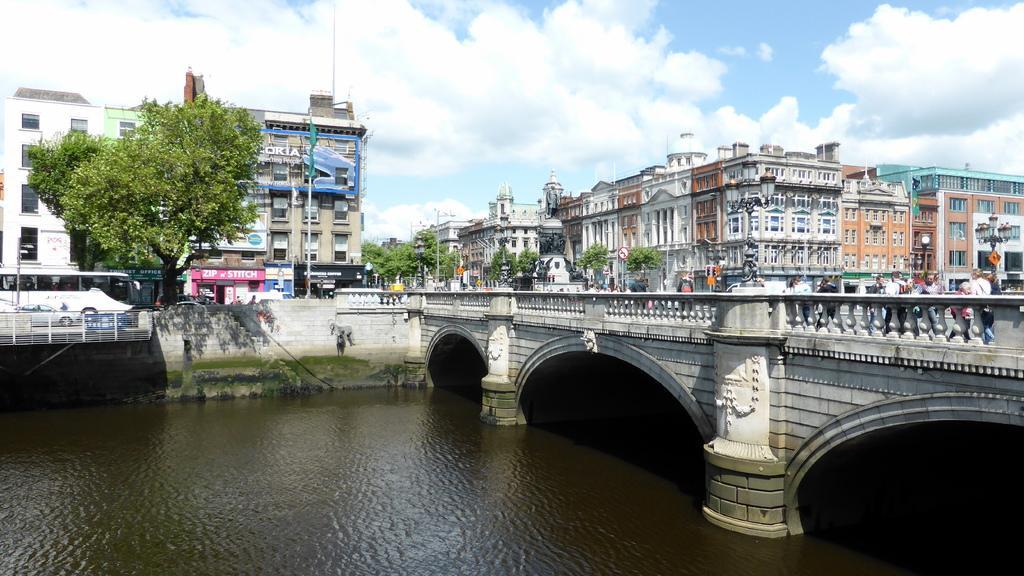Describe this image in one or two sentences. At the bottom of the image there is water. On the right side of the image there is a bridge with arches, pillars and railings. On the bridge there are few people standing and also there are poles with lamps. Behind the water there is a wall with railing. Behind the railing there is a bus. In the background there are trees, buildings with walls, glass windows, pillars and roofs. And also there are poles with sign boards. At the top of the image there is a sky with clouds. 